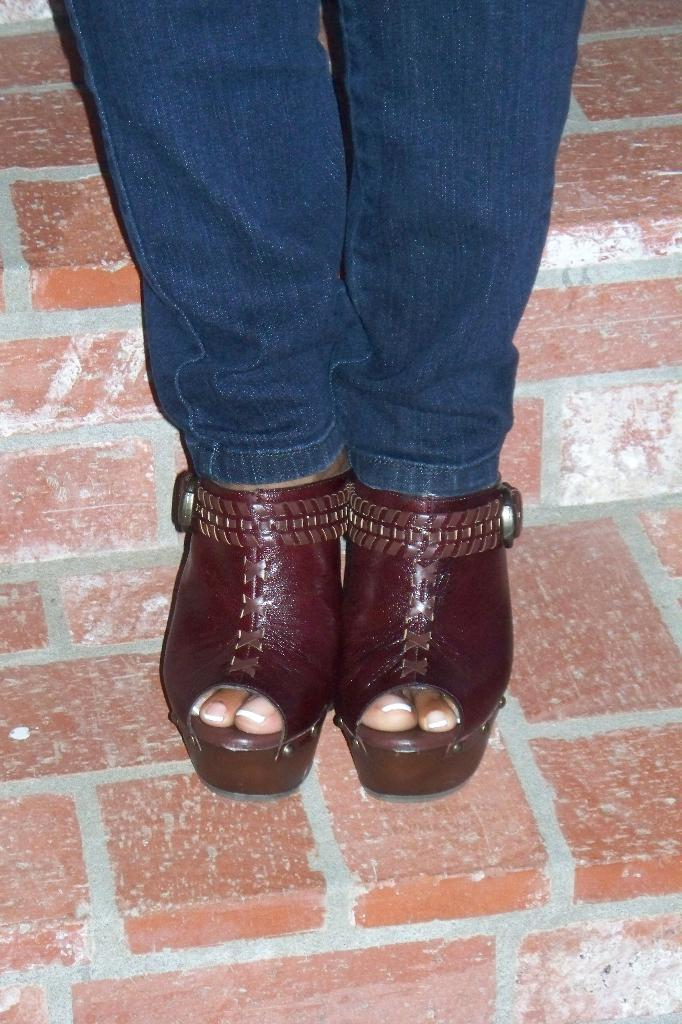What is present in the image? There is a person in the image. What type of footwear is the person wearing? The person is wearing sandals. Where is the person located in the image? The person is standing on the floor. What type of lace is the person using to tie their sandals in the image? There is no mention of lace in the image, as the person is wearing sandals, which typically do not require laces. 